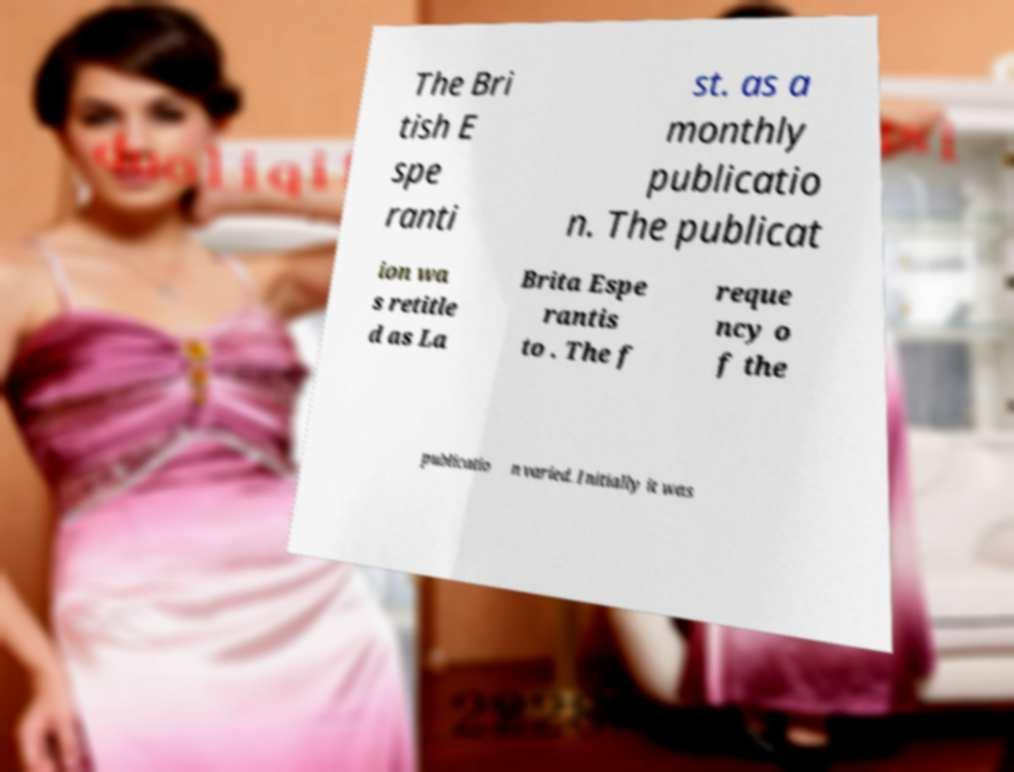For documentation purposes, I need the text within this image transcribed. Could you provide that? The Bri tish E spe ranti st. as a monthly publicatio n. The publicat ion wa s retitle d as La Brita Espe rantis to . The f reque ncy o f the publicatio n varied. Initially it was 